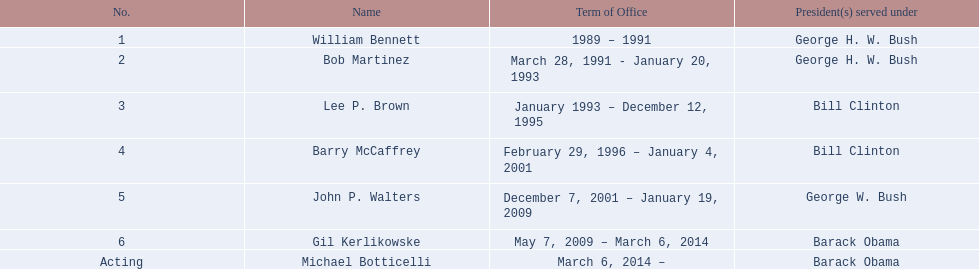How many directors had a tenure exceeding 3 years? 3. 